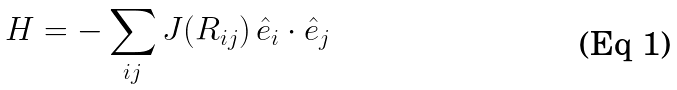<formula> <loc_0><loc_0><loc_500><loc_500>H = - \sum _ { i j } J ( R _ { i j } ) \, { \hat { e } _ { i } } \cdot { \hat { e } _ { j } }</formula> 